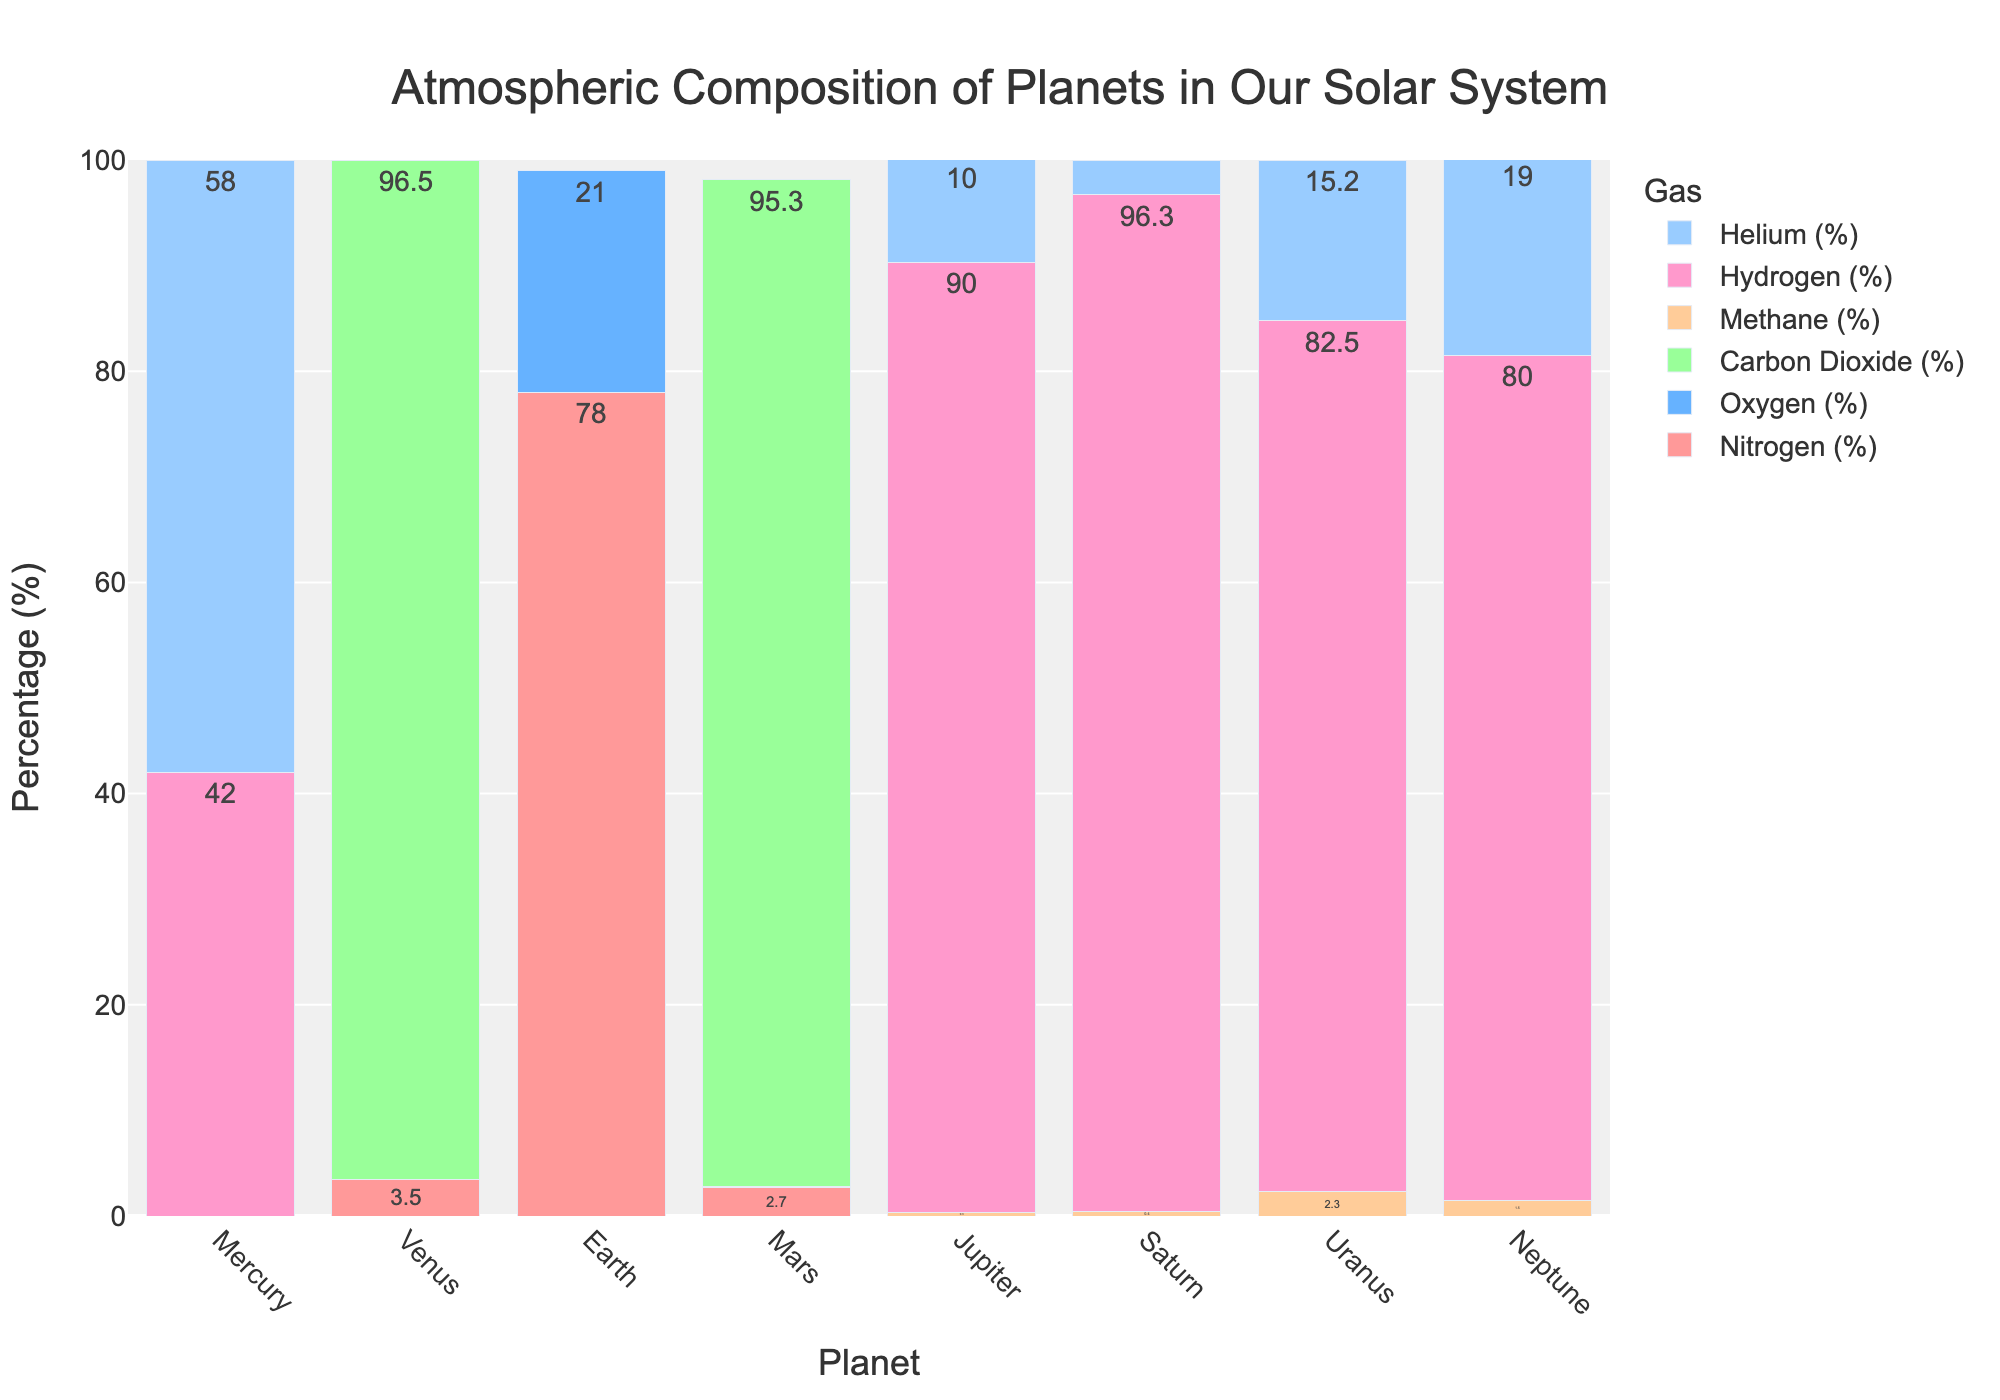what is the planet with the highest percentage of Oxygen? From the bar chart, look at the different planets and find the one with the tallest bar for Oxygen. This planet's name is Earth, as it has a 21% Oxygen composition.
Answer: Earth Which planet has the highest total percentage of Hydrogen and Helium? To find the planet with the highest total percentage of Hydrogen and Helium, sum the percentages of Hydrogen and Helium for each planet and compare them. Saturn has 96.3% Hydrogen and 3.3% Helium which sums up to 99.6%, the highest total.
Answer: Saturn Which planet has the lowest percentage of Carbon Dioxide? Looking at the Carbon Dioxide bars, compare the heights across all planets. Earth has the lowest percentage with 0.04% of Carbon Dioxide.
Answer: Earth What is the difference between the percentage of Nitrogen on Earth and Venus? The bar chart shows Earth has 78% Nitrogen and Venus has 3.5% Nitrogen. Subtract Venus' percentage from Earth's: 78% - 3.5% = 74.5%.
Answer: 74.5% Which planets have no Oxygen in their atmospheres? Identify the planets with bars showing 0% for Oxygen. These planets are Mercury, Venus, Mars, Jupiter, Saturn, Uranus, and Neptune.
Answer: Mercury, Venus, Mars, Jupiter, Saturn, Uranus, Neptune How does the percentage of Methane in Uranus compare to Neptune? The Methane bar for Uranus is 2.3% and for Neptune is 1.5%. Uranus has a higher percentage of Methane compared to Neptune.
Answer: Uranus has more Methane What is the average percentage of Carbon Dioxide on Venus and Mars? Add Venus' and Mars' Carbon Dioxide percentages (96.5% and 95.3%) then divide by 2. (96.5% + 95.3%) / 2 = 95.9%.
Answer: 95.9% Which planet has a higher percentage of Hydrogen, Jupiter or Neptune? Comparing the heights of Hydrogen bars for Jupiter (90%) and Neptune (80%), Jupiter has a higher percentage of Hydrogen.
Answer: Jupiter What is the combined percentage of Methane and Helium on Saturn? Sum the bars for Methane (0.4%) and Helium (3.3%) on Saturn. 0.4% + 3.3% = 3.7%.
Answer: 3.7% Which planet has the smallest percentage of Nitrogen, Earth or Mars? Compare Nitrogen bars for Earth (78%) and Mars (2.7%). Mars has the smallest percentage.
Answer: Mars 